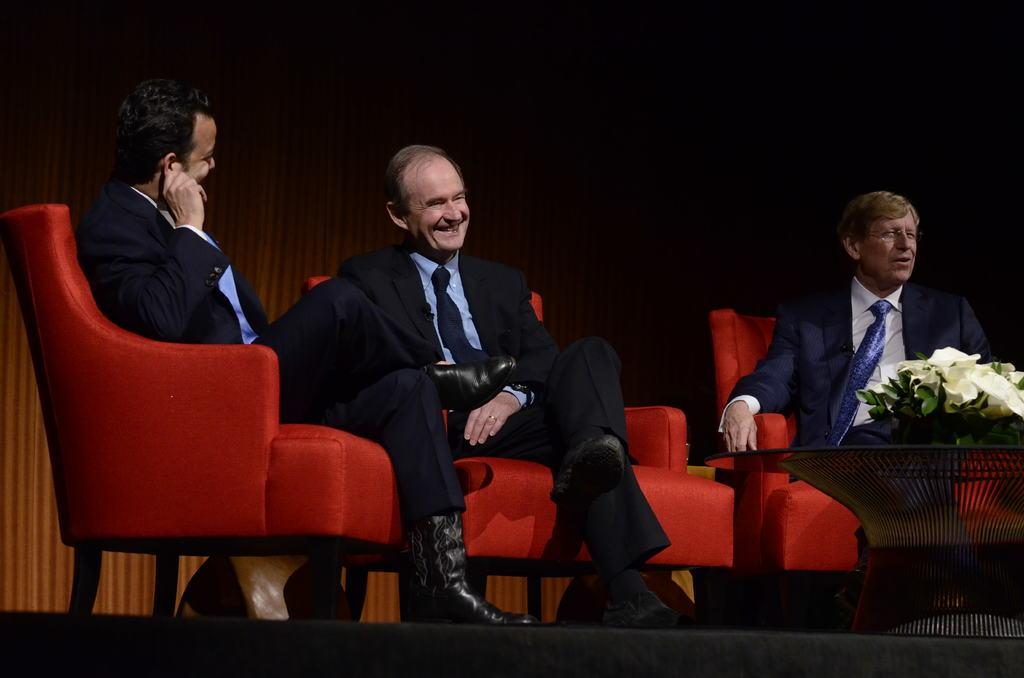How many people are in the image? There are three men in the image. What are the men doing in the image? The men are sitting on chairs. What is in front of the men? There is a table in front of the men. What is on the table? There is a flower pot on the table. What type of crayon is the actor using in the image? There is no actor or crayon present in the image. 